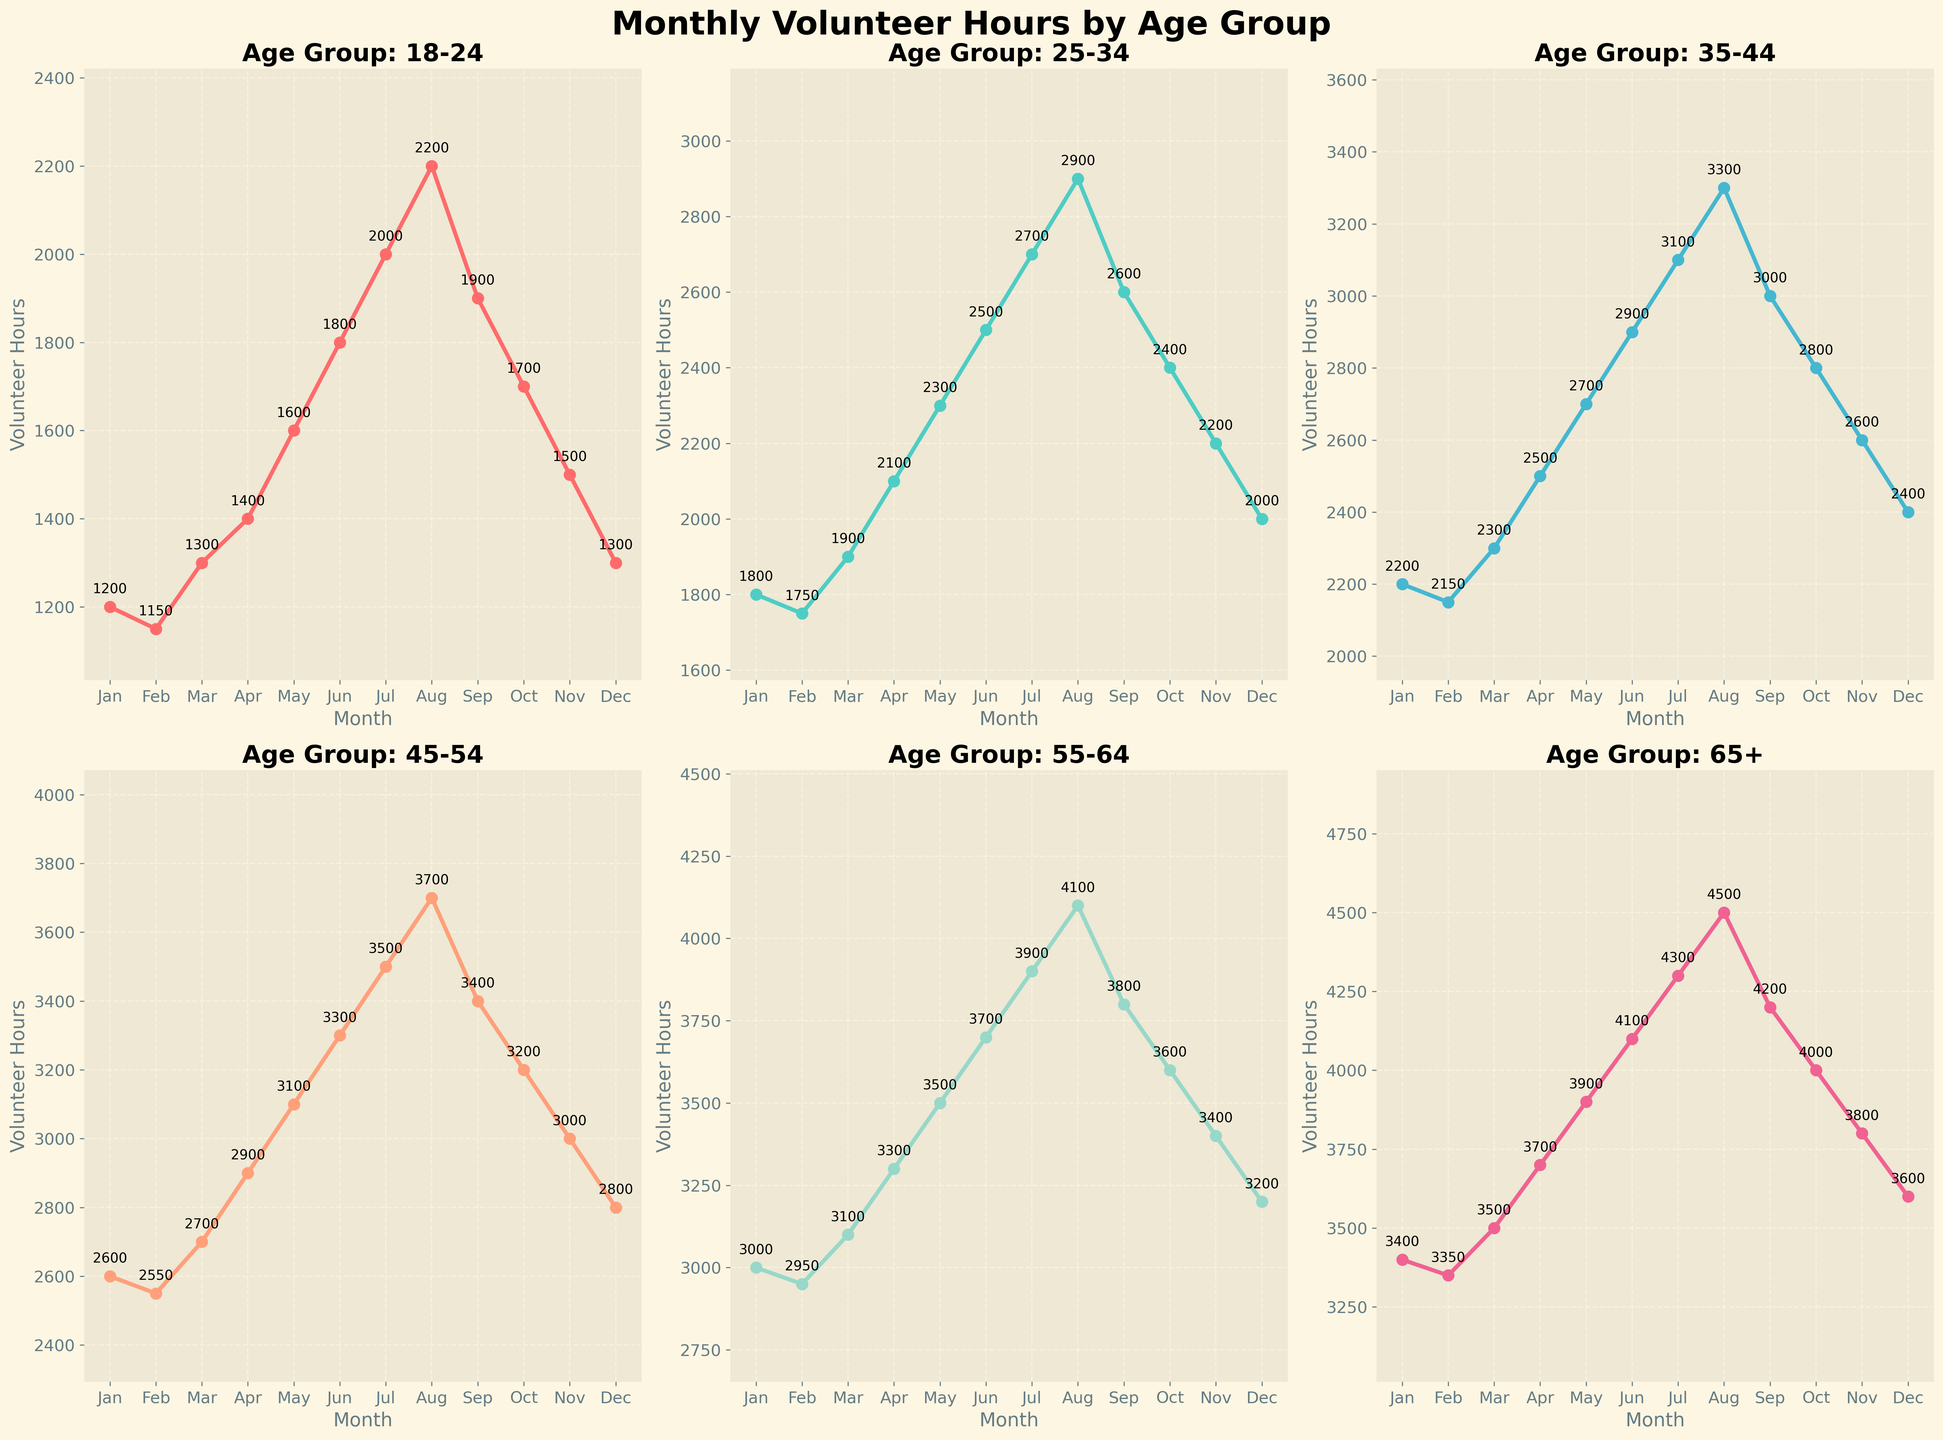What's the trend of volunteer hours for the 65+ age group throughout the year? The 65+ age group's volunteer hours show a consistent increasing trend from January to August, peaking in August at 4500 hours, followed by a decreasing trend towards December, ending at 3600 hours.
Answer: Increasing to August, then decreasing Which age group contributed the most volunteer hours in March? By looking at the subplot titles and comparing the heights of the lines, the 65+ age group has the highest point in March at 3500 hours.
Answer: 65+ How many more volunteer hours did the 55-64 age group contribute in June compared to February? The 55-64 age group contributed 3700 hours in June and 2950 hours in February. Subtracting 2950 from 3700 gives 750 additional hours.
Answer: 750 What was the total volunteer hours contributed in May by all age groups? Summing the May values for all age groups (1600 + 2300 + 2700 + 3100 + 3500 + 3900) gives a total of 17100 hours.
Answer: 17100 Which two months have the highest volunteer hours for the 35-44 age group? Observing the plot for the 35-44 age group, the two highest peaks are in August and July, where the values are 3300 and 3100 hours, respectively.
Answer: August and July By how much did the volunteer hours for the 18-24 age group increase from January to July? The 18-24 age group contributed 1200 hours in January and 2000 hours in July. Subtracting 1200 from 2000 gives an increase of 800 hours.
Answer: 800 Is the pattern of volunteer hours for the 25-34 age group more similar to the 35-44 age group or the 45-54 age group? The 25-34 age group has peaks and troughs that closely follow the pattern of the 35-44 age group, with both having gradual increases and decreases at similar times of the year. The 45-54 age group's pattern is not as similar.
Answer: 35-44 age group Which age group has the least fluctuation in volunteer hours throughout the year? By observing the spread of the lines, the 65+ age group has the most steady and consistent increase and decrease with relatively smoother transitions compared to other age groups.
Answer: 65+ What is the difference in volunteer hours between the 45-54 and 55-64 age groups in December? The 45-54 age group has 2800 hours and the 55-64 age group has 3200 hours in December. The difference is 3200 - 2800 = 400 hours.
Answer: 400 Was there any age group that steadily increased their volunteer hours every month from January to December? By closely examining each subplot line, none of the age groups shows a steady and uninterrupted increase every month; all experience some decline or plateau.
Answer: No 